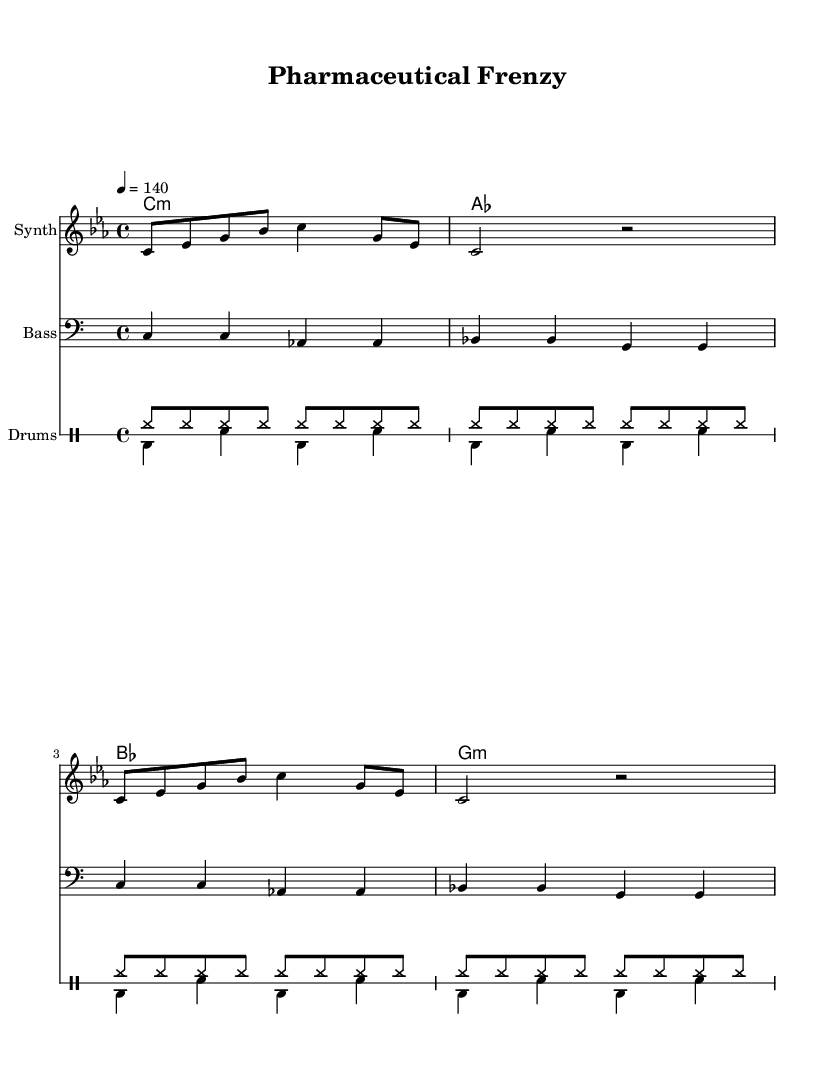What is the key signature of this music? The key signature is C minor, indicated by the presence of three flats (B♭, E♭, A♭) in the key signature.
Answer: C minor What is the time signature of this piece? The time signature is 4/4, which means there are four beats in each measure and the quarter note receives one beat.
Answer: 4/4 What tempo marking is indicated in the score? The tempo marking shows a speed of 140 beats per minute, indicated by the note "4 = 140" in the tempo line.
Answer: 140 How many measures are there in the melody section? There are a total of eight measures in the provided melody section, which can be counted by observing the divisions in the notation.
Answer: 8 What type of percussion instruments are used in this piece? The score features hi-hat and bass drum as indicated by the respective notations for drums in the 'drummode' section.
Answer: Hi-hat and bass drum What is the last chord played in the harmony? The last chord in the harmony is G minor, as indicated by the chord symbol in the last measure of the chord mode section.
Answer: G minor How does the bass line relate to the melody? The bass line follows a descending pattern that complements the melody, providing a harmonic foundation that enhances the musical texture.
Answer: Descending pattern 